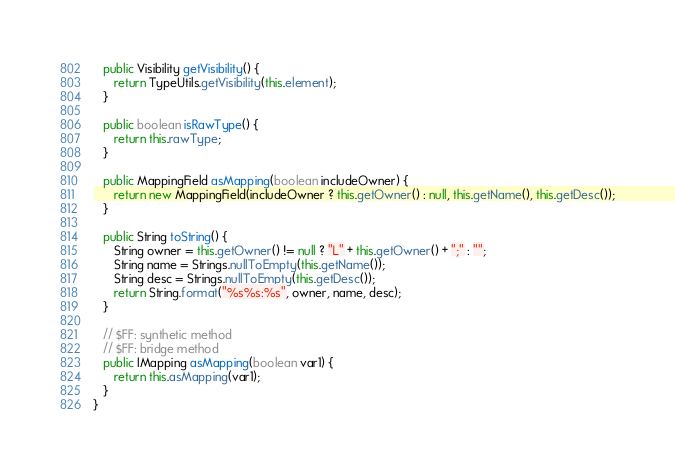<code> <loc_0><loc_0><loc_500><loc_500><_Java_>
   public Visibility getVisibility() {
      return TypeUtils.getVisibility(this.element);
   }

   public boolean isRawType() {
      return this.rawType;
   }

   public MappingField asMapping(boolean includeOwner) {
      return new MappingField(includeOwner ? this.getOwner() : null, this.getName(), this.getDesc());
   }

   public String toString() {
      String owner = this.getOwner() != null ? "L" + this.getOwner() + ";" : "";
      String name = Strings.nullToEmpty(this.getName());
      String desc = Strings.nullToEmpty(this.getDesc());
      return String.format("%s%s:%s", owner, name, desc);
   }

   // $FF: synthetic method
   // $FF: bridge method
   public IMapping asMapping(boolean var1) {
      return this.asMapping(var1);
   }
}
</code> 